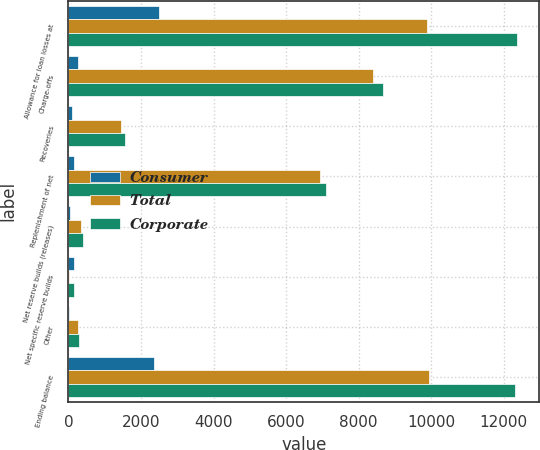Convert chart. <chart><loc_0><loc_0><loc_500><loc_500><stacked_bar_chart><ecel><fcel>Allowance for loan losses at<fcel>Charge-offs<fcel>Recoveries<fcel>Replenishment of net<fcel>Net reserve builds (releases)<fcel>Net specific reserve builds<fcel>Other<fcel>Ending balance<nl><fcel>Consumer<fcel>2486<fcel>271<fcel>102<fcel>169<fcel>56<fcel>159<fcel>18<fcel>2365<nl><fcel>Total<fcel>9869<fcel>8394<fcel>1450<fcel>6944<fcel>338<fcel>6<fcel>263<fcel>9950<nl><fcel>Corporate<fcel>12355<fcel>8665<fcel>1552<fcel>7113<fcel>394<fcel>153<fcel>281<fcel>12315<nl></chart> 